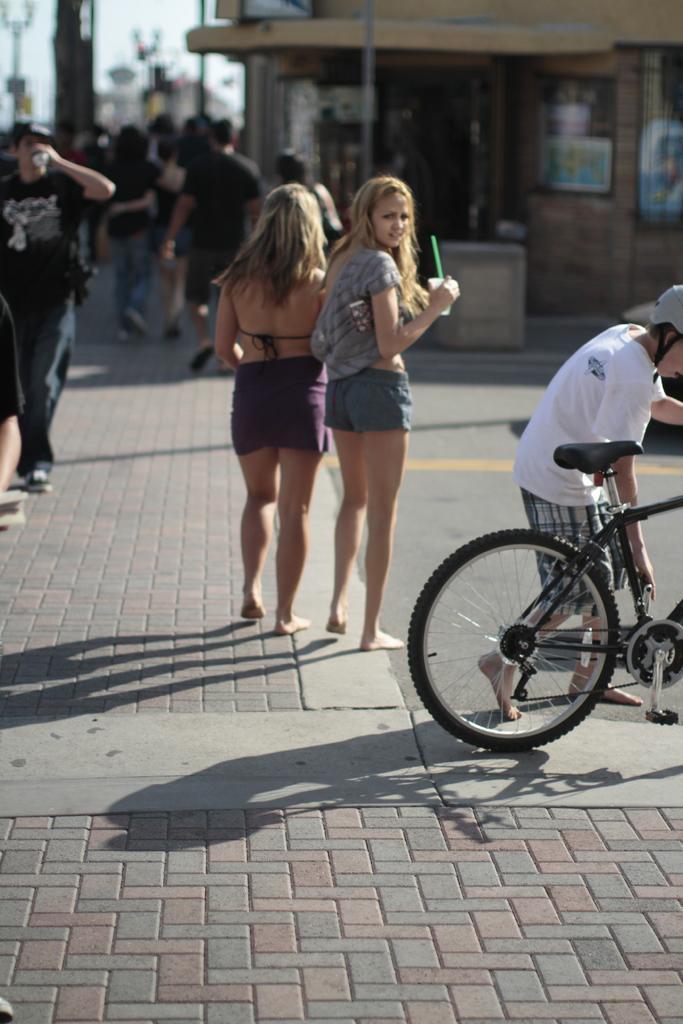In one or two sentences, can you explain what this image depicts? In the image I can see two people, a person beside the bicycle and around I can see some other buildings and people. 